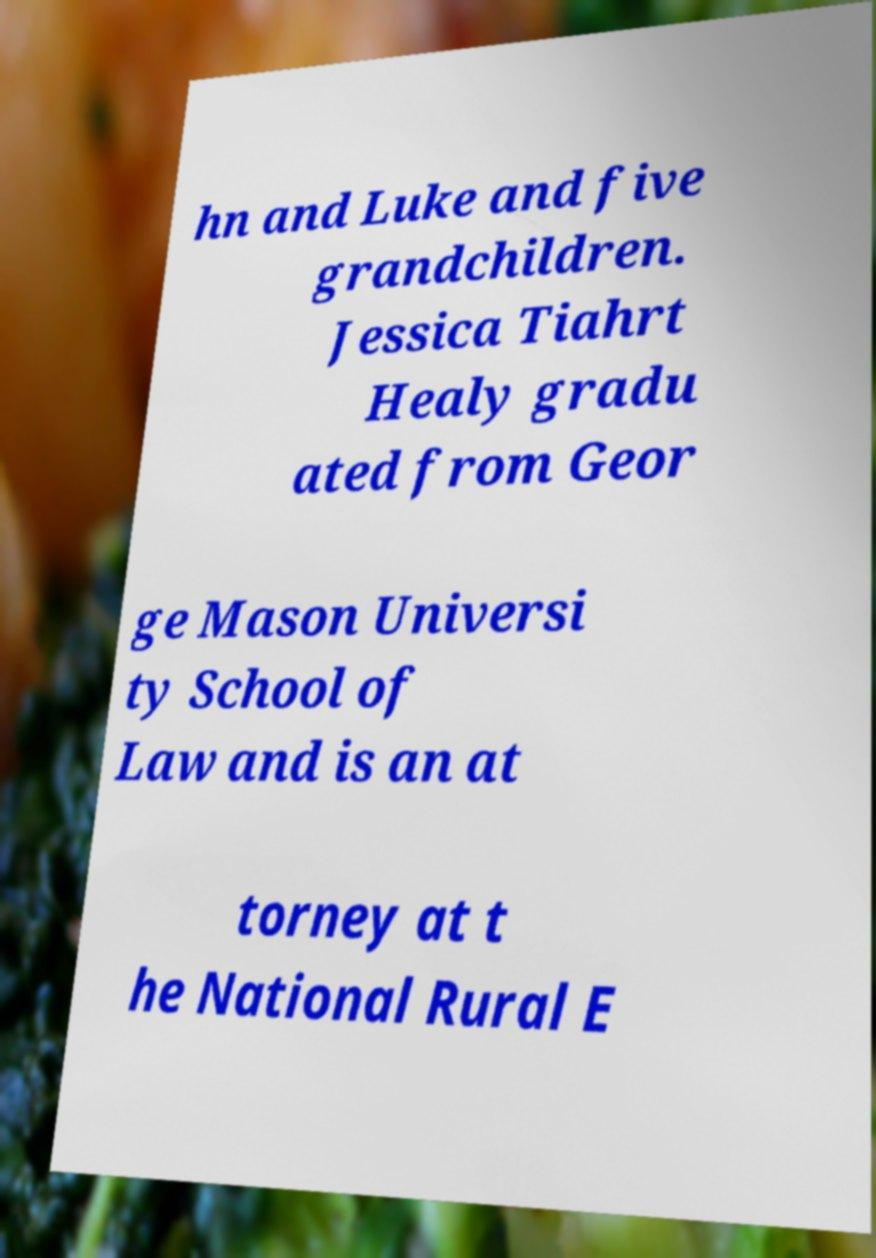Can you read and provide the text displayed in the image?This photo seems to have some interesting text. Can you extract and type it out for me? hn and Luke and five grandchildren. Jessica Tiahrt Healy gradu ated from Geor ge Mason Universi ty School of Law and is an at torney at t he National Rural E 